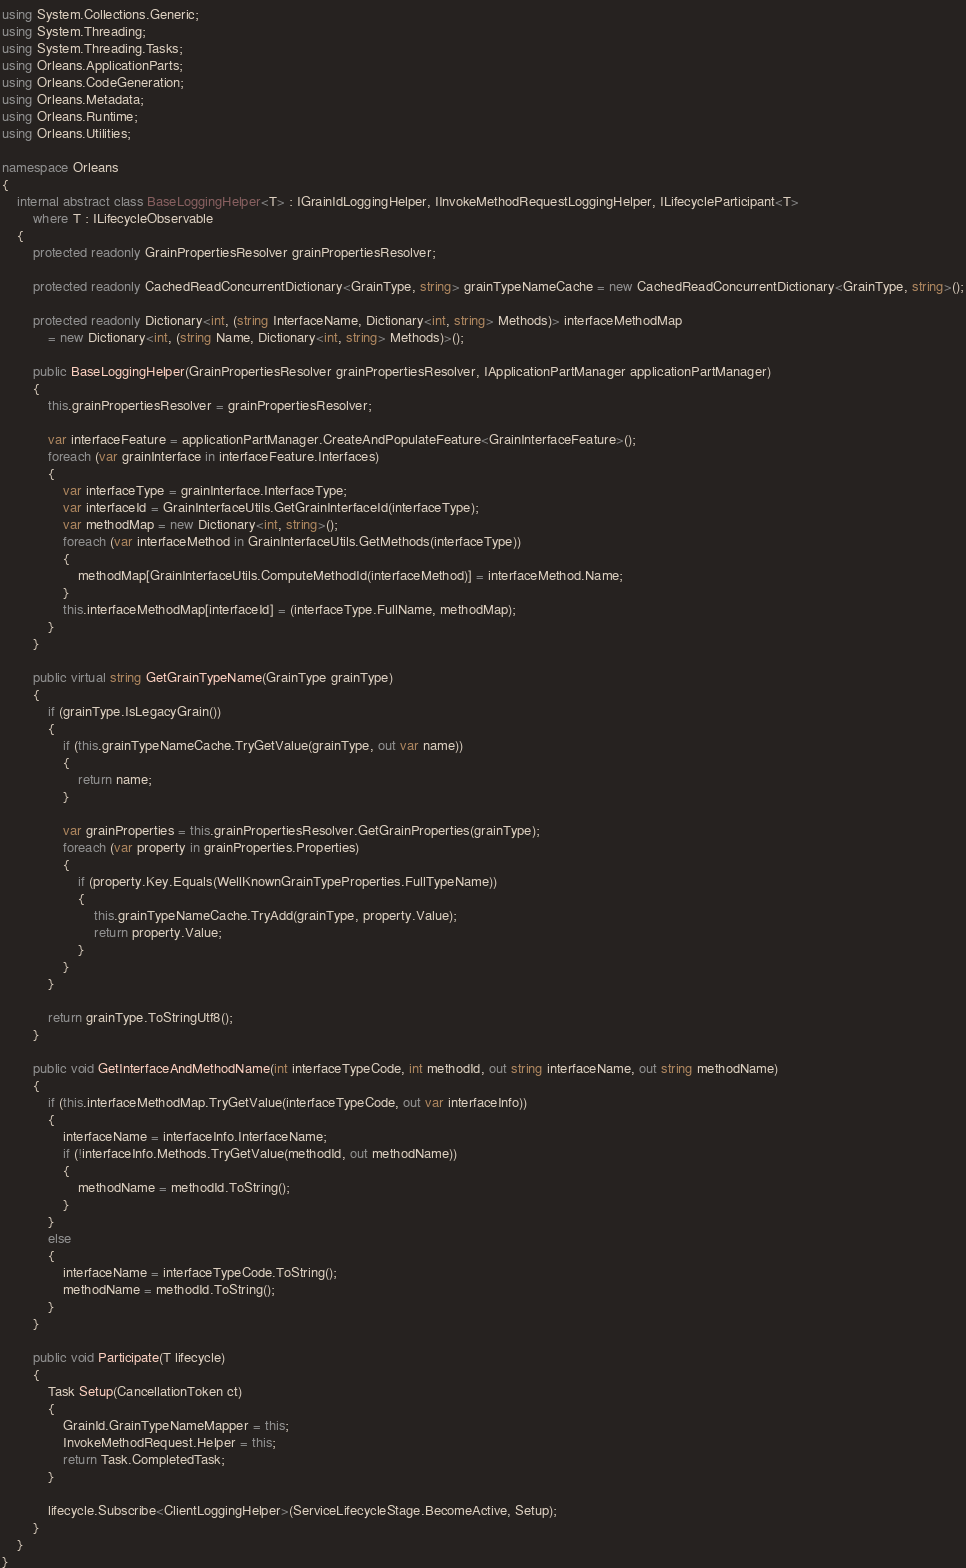<code> <loc_0><loc_0><loc_500><loc_500><_C#_>using System.Collections.Generic;
using System.Threading;
using System.Threading.Tasks;
using Orleans.ApplicationParts;
using Orleans.CodeGeneration;
using Orleans.Metadata;
using Orleans.Runtime;
using Orleans.Utilities;

namespace Orleans
{
    internal abstract class BaseLoggingHelper<T> : IGrainIdLoggingHelper, IInvokeMethodRequestLoggingHelper, ILifecycleParticipant<T>
        where T : ILifecycleObservable
    {
        protected readonly GrainPropertiesResolver grainPropertiesResolver;

        protected readonly CachedReadConcurrentDictionary<GrainType, string> grainTypeNameCache = new CachedReadConcurrentDictionary<GrainType, string>();

        protected readonly Dictionary<int, (string InterfaceName, Dictionary<int, string> Methods)> interfaceMethodMap
            = new Dictionary<int, (string Name, Dictionary<int, string> Methods)>();

        public BaseLoggingHelper(GrainPropertiesResolver grainPropertiesResolver, IApplicationPartManager applicationPartManager)
        {
            this.grainPropertiesResolver = grainPropertiesResolver;

            var interfaceFeature = applicationPartManager.CreateAndPopulateFeature<GrainInterfaceFeature>();
            foreach (var grainInterface in interfaceFeature.Interfaces)
            {
                var interfaceType = grainInterface.InterfaceType;
                var interfaceId = GrainInterfaceUtils.GetGrainInterfaceId(interfaceType);
                var methodMap = new Dictionary<int, string>();
                foreach (var interfaceMethod in GrainInterfaceUtils.GetMethods(interfaceType))
                {
                    methodMap[GrainInterfaceUtils.ComputeMethodId(interfaceMethod)] = interfaceMethod.Name;
                }
                this.interfaceMethodMap[interfaceId] = (interfaceType.FullName, methodMap);
            }
        }

        public virtual string GetGrainTypeName(GrainType grainType)
        {
            if (grainType.IsLegacyGrain())
            {
                if (this.grainTypeNameCache.TryGetValue(grainType, out var name))
                {
                    return name;
                }

                var grainProperties = this.grainPropertiesResolver.GetGrainProperties(grainType);
                foreach (var property in grainProperties.Properties)
                {
                    if (property.Key.Equals(WellKnownGrainTypeProperties.FullTypeName))
                    {
                        this.grainTypeNameCache.TryAdd(grainType, property.Value);
                        return property.Value;
                    }
                }
            }

            return grainType.ToStringUtf8();
        }

        public void GetInterfaceAndMethodName(int interfaceTypeCode, int methodId, out string interfaceName, out string methodName)
        {
            if (this.interfaceMethodMap.TryGetValue(interfaceTypeCode, out var interfaceInfo))
            {
                interfaceName = interfaceInfo.InterfaceName;
                if (!interfaceInfo.Methods.TryGetValue(methodId, out methodName))
                {
                    methodName = methodId.ToString();
                }
            }
            else
            {
                interfaceName = interfaceTypeCode.ToString();
                methodName = methodId.ToString();
            }
        }

        public void Participate(T lifecycle)
        {
            Task Setup(CancellationToken ct)
            {
                GrainId.GrainTypeNameMapper = this;
                InvokeMethodRequest.Helper = this;
                return Task.CompletedTask;
            }

            lifecycle.Subscribe<ClientLoggingHelper>(ServiceLifecycleStage.BecomeActive, Setup);
        }
    }
}
</code> 